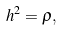Convert formula to latex. <formula><loc_0><loc_0><loc_500><loc_500>h ^ { 2 } = \rho ,</formula> 